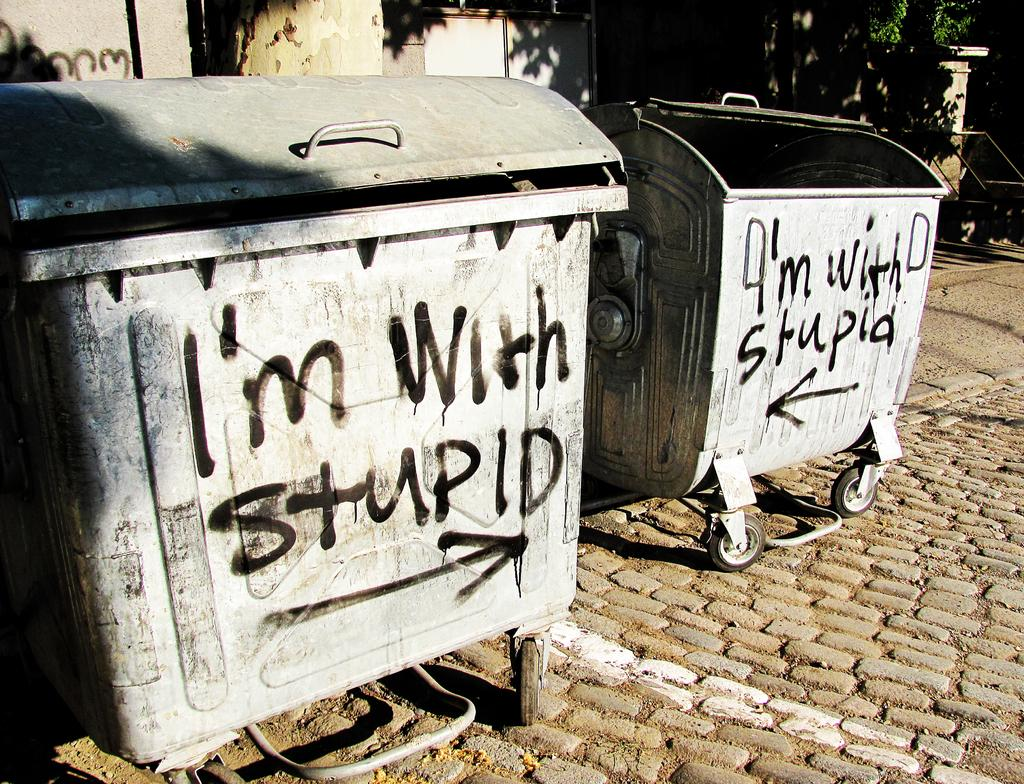<image>
Share a concise interpretation of the image provided. I'm with stupid graffiti is doubled up on these dumpsters which point at each other. 